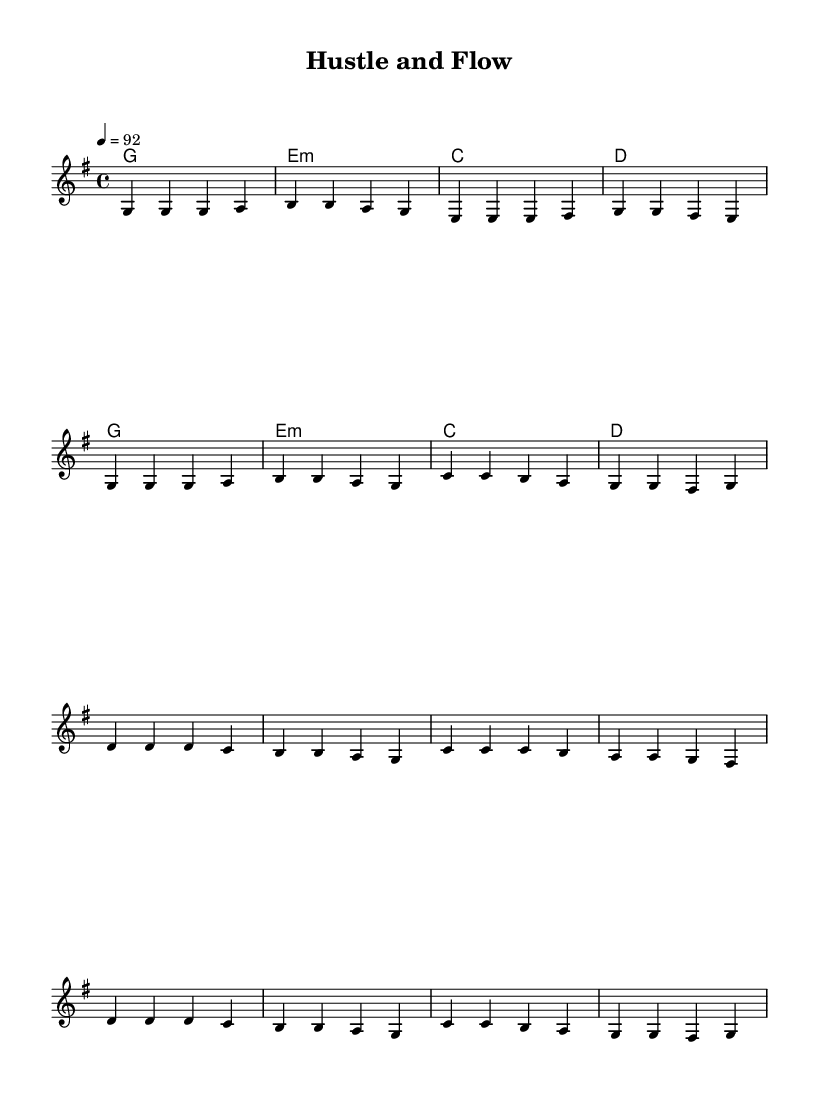What is the key signature of this music? The key signature is G major, indicated by one sharp (F#) at the beginning of the staff.
Answer: G major What is the time signature of this piece? The time signature is 4/4, which means there are four beats per measure. This is typically found at the beginning of the staff.
Answer: 4/4 What is the tempo marking provided in the score? The tempo marking indicates a speed of 92 beats per minute, which is specified at the beginning of the score.
Answer: 92 How many measures are in the verse section? The verse section is composed of 8 measures, as counted from the notation written above the staff.
Answer: 8 measures What type of harmony is presented in the piece? The harmony consists of major and minor chords, with G major as the tonic chord being used predominantly throughout the score.
Answer: Major and minor What is the main theme reflected in the lyrics of the chorus? The chorus emphasizes perseverance and growth in the context of e-commerce and entrepreneurial success, highlighting motivation and resilience.
Answer: Perseverance and growth What rhythmic style is typical for reggae music, as seen in this piece? The rhythmic style typical in reggae is characterized by a one drop rhythm which is reflected in the melody and the overall flow of the song's structure.
Answer: One drop rhythm 